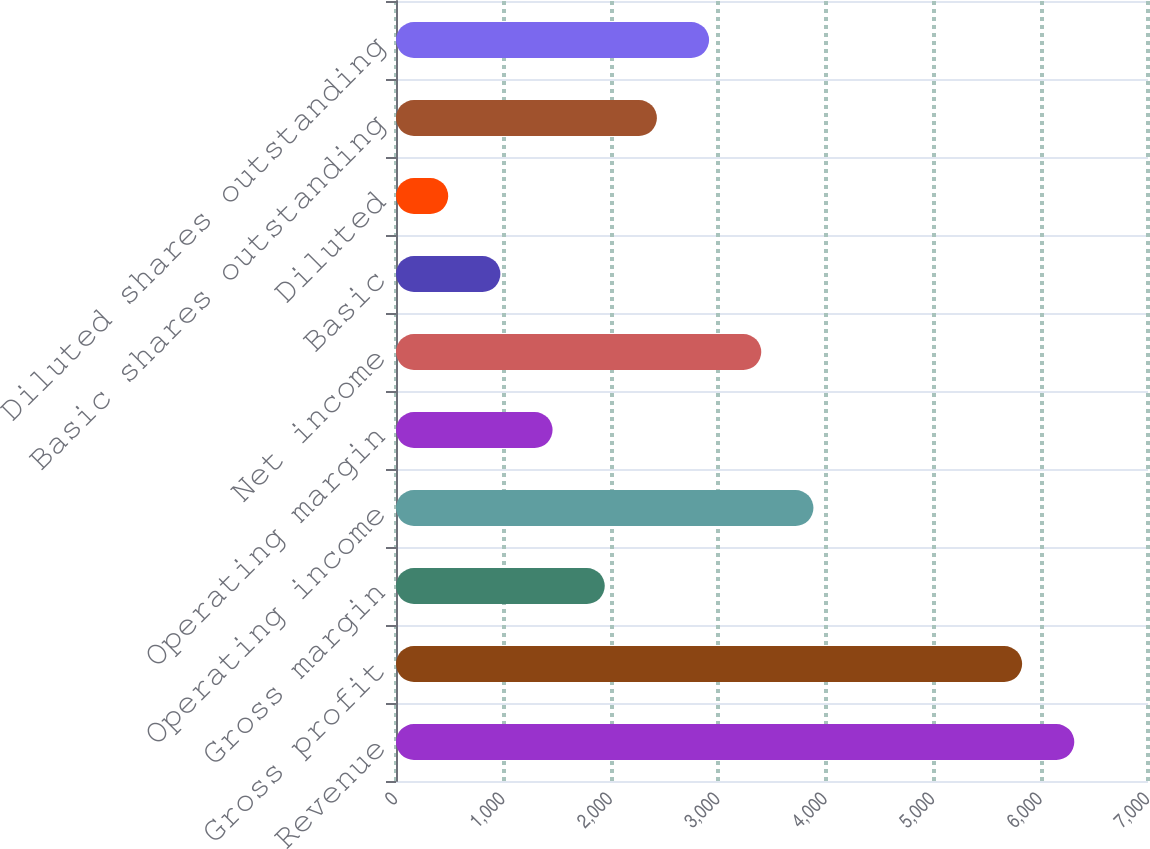<chart> <loc_0><loc_0><loc_500><loc_500><bar_chart><fcel>Revenue<fcel>Gross profit<fcel>Gross margin<fcel>Operating income<fcel>Operating margin<fcel>Net income<fcel>Basic<fcel>Diluted<fcel>Basic shares outstanding<fcel>Diluted shares outstanding<nl><fcel>6313.92<fcel>5828.27<fcel>1943.07<fcel>3885.67<fcel>1457.42<fcel>3400.02<fcel>971.77<fcel>486.12<fcel>2428.72<fcel>2914.37<nl></chart> 